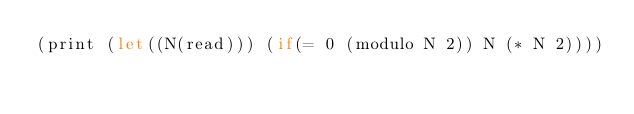Convert code to text. <code><loc_0><loc_0><loc_500><loc_500><_Scheme_>(print (let((N(read))) (if(= 0 (modulo N 2)) N (* N 2))))</code> 